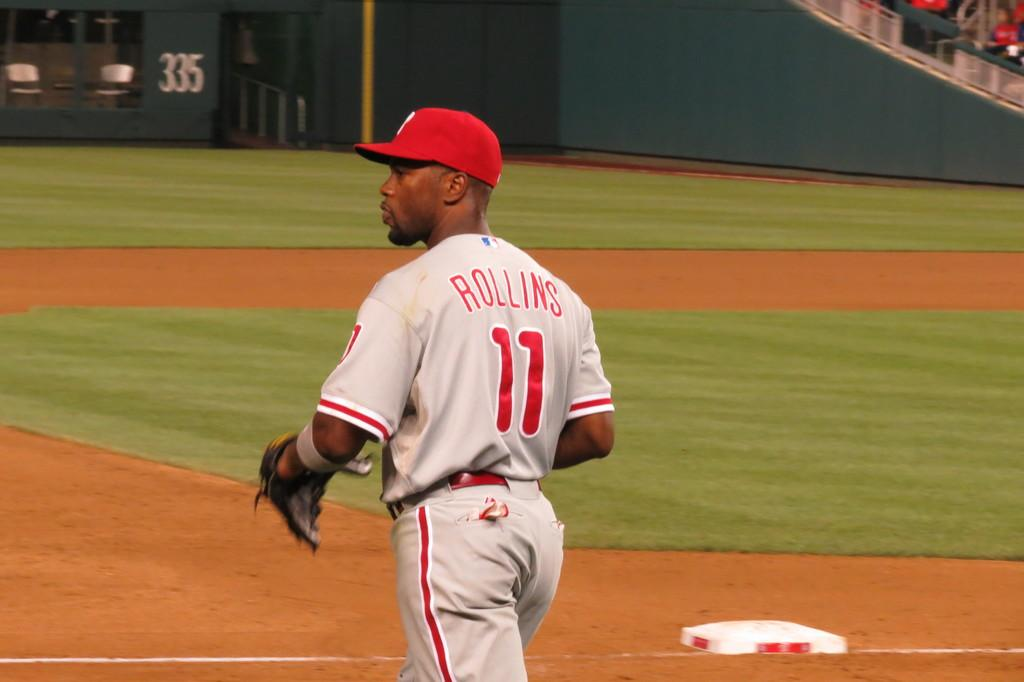<image>
Write a terse but informative summary of the picture. Rollins is player number 11 on this baseball team. 